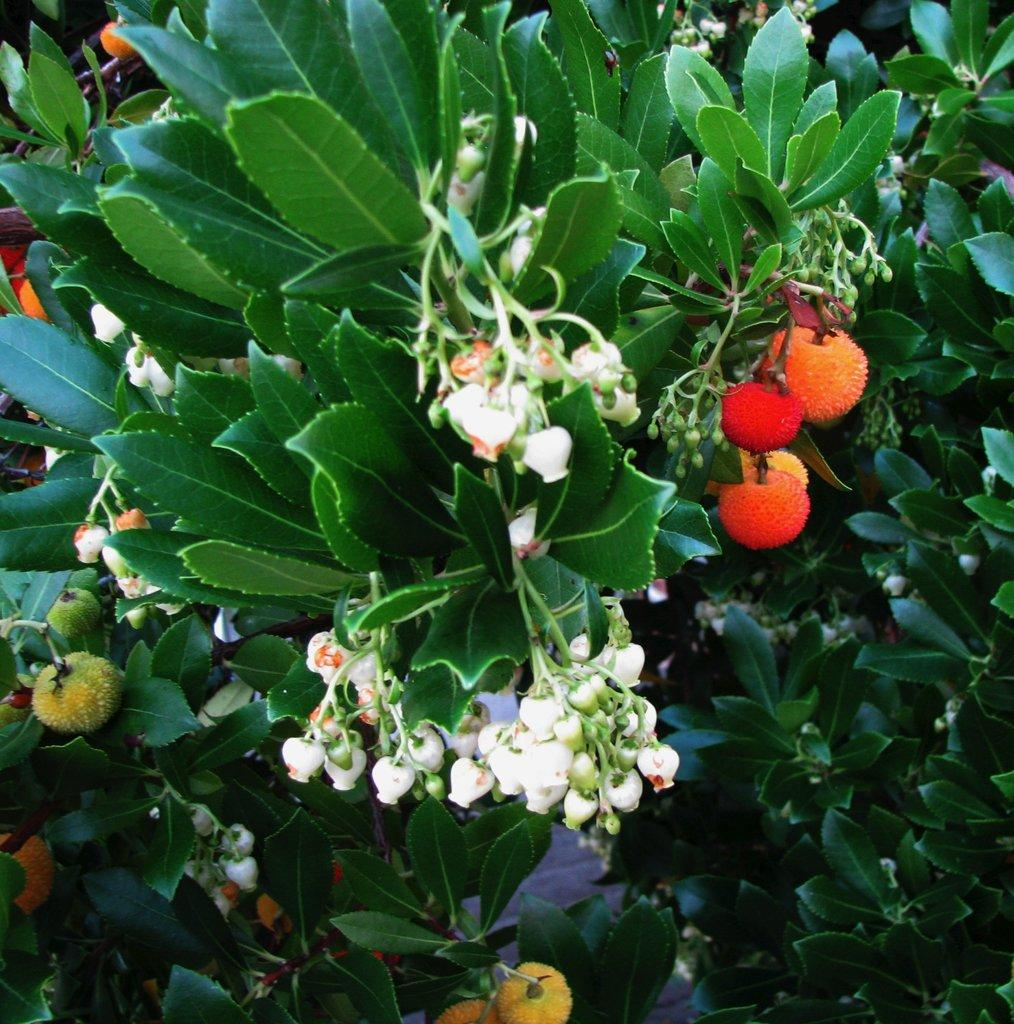What type of living organisms can be seen in the image? Plants, flowers, and fruits are visible in the image. Can you describe the flowers in the image? Yes, there are flowers in the image. What type of fruits can be seen in the image? Fruits are present in the image. What type of headwear is the kitten wearing in the image? There is no kitten present in the image, so it is not possible to determine what type of headwear the kitten might be wearing. 